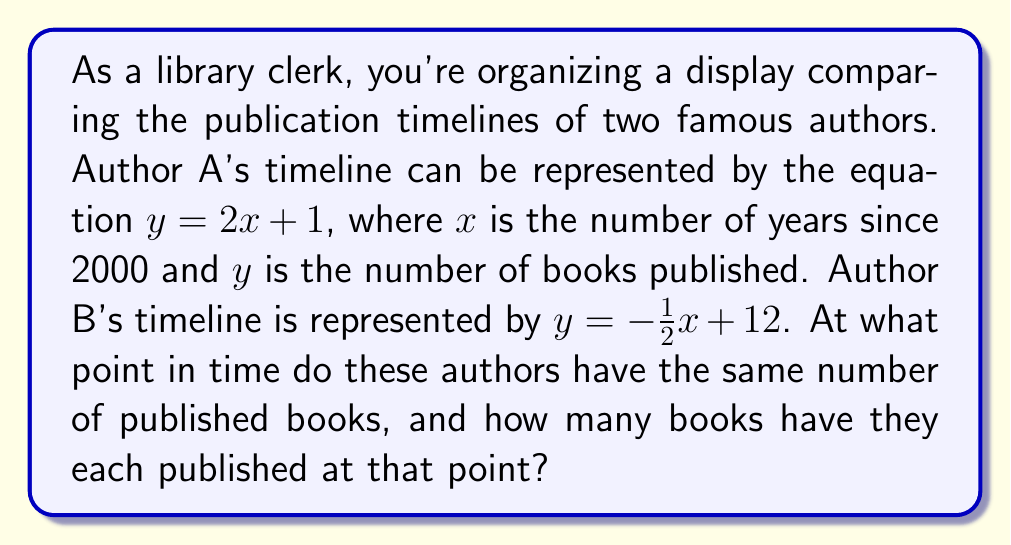Can you solve this math problem? To solve this problem, we need to find the intersection point of the two lines representing the authors' publication timelines. Let's approach this step-by-step:

1) We have two equations:
   Author A: $y = 2x + 1$
   Author B: $y = -\frac{1}{2}x + 12$

2) At the intersection point, the $y$ values (number of books) will be equal for both authors. So we can set the equations equal to each other:

   $2x + 1 = -\frac{1}{2}x + 12$

3) Now we solve for $x$:
   $2x + 1 = -\frac{1}{2}x + 12$
   $2x + \frac{1}{2}x = 12 - 1$
   $\frac{5}{2}x = 11$
   $x = \frac{11}{\frac{5}{2}} = \frac{22}{5} = 4.4$

4) This means the authors' timelines intersect 4.4 years after 2000, which is mid-2004.

5) To find the number of books published at this point, we can substitute $x = 4.4$ into either equation. Let's use Author A's equation:

   $y = 2(4.4) + 1 = 8.8 + 1 = 9.8$

Therefore, at the intersection point, each author has published 9.8 books (which in reality would be rounded to 10 books).
Answer: The authors have the same number of published books 4.4 years after 2000 (mid-2004), at which point they have each published 9.8 books. 